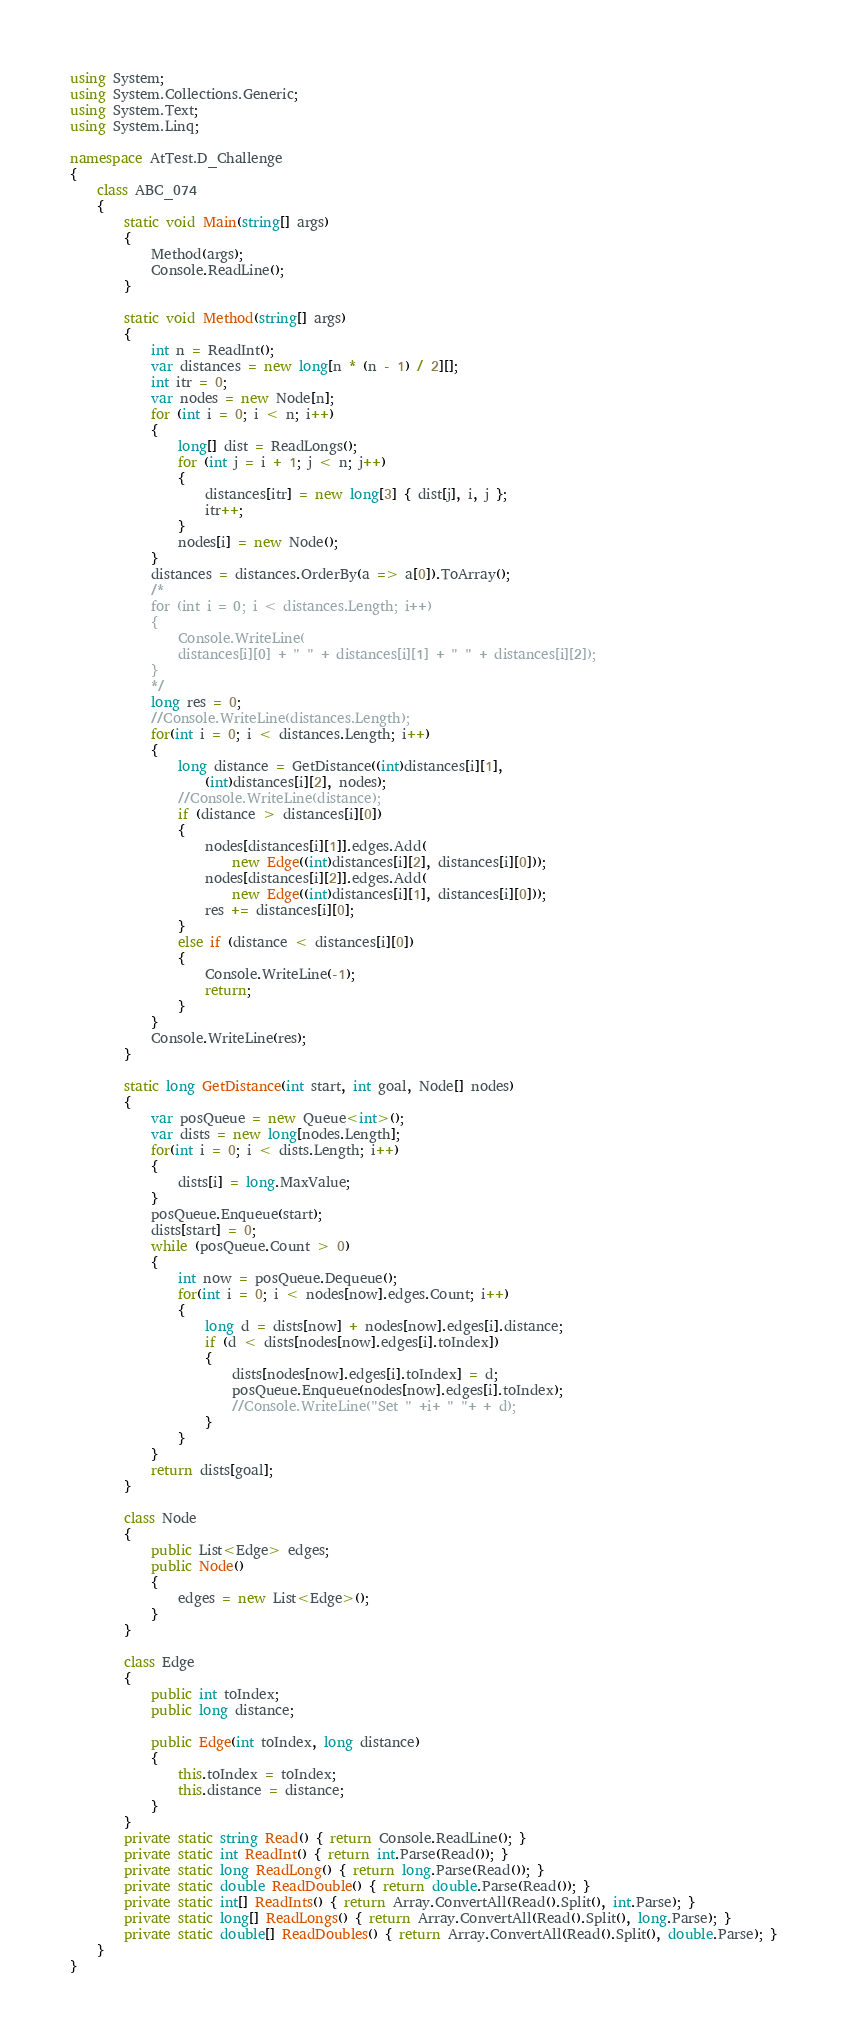Convert code to text. <code><loc_0><loc_0><loc_500><loc_500><_C#_>using System;
using System.Collections.Generic;
using System.Text;
using System.Linq;

namespace AtTest.D_Challenge
{
    class ABC_074
    {
        static void Main(string[] args)
        {
            Method(args);
            Console.ReadLine();
        }

        static void Method(string[] args)
        {
            int n = ReadInt();
            var distances = new long[n * (n - 1) / 2][];
            int itr = 0;
            var nodes = new Node[n];
            for (int i = 0; i < n; i++)
            {
                long[] dist = ReadLongs();
                for (int j = i + 1; j < n; j++)
                {
                    distances[itr] = new long[3] { dist[j], i, j };
                    itr++;
                }
                nodes[i] = new Node();
            }
            distances = distances.OrderBy(a => a[0]).ToArray();
            /*
            for (int i = 0; i < distances.Length; i++)
            {
                Console.WriteLine(
                distances[i][0] + " " + distances[i][1] + " " + distances[i][2]);
            }
            */
            long res = 0;
            //Console.WriteLine(distances.Length);
            for(int i = 0; i < distances.Length; i++)
            {
                long distance = GetDistance((int)distances[i][1],
                    (int)distances[i][2], nodes);
                //Console.WriteLine(distance);
                if (distance > distances[i][0])
                {
                    nodes[distances[i][1]].edges.Add(
                        new Edge((int)distances[i][2], distances[i][0]));
                    nodes[distances[i][2]].edges.Add(
                        new Edge((int)distances[i][1], distances[i][0]));
                    res += distances[i][0];
                }
                else if (distance < distances[i][0])
                {
                    Console.WriteLine(-1);
                    return;
                }
            }
            Console.WriteLine(res);
        }

        static long GetDistance(int start, int goal, Node[] nodes)
        {
            var posQueue = new Queue<int>();
            var dists = new long[nodes.Length];
            for(int i = 0; i < dists.Length; i++)
            {
                dists[i] = long.MaxValue;
            }
            posQueue.Enqueue(start);
            dists[start] = 0;
            while (posQueue.Count > 0)
            {
                int now = posQueue.Dequeue();
                for(int i = 0; i < nodes[now].edges.Count; i++)
                {
                    long d = dists[now] + nodes[now].edges[i].distance;
                    if (d < dists[nodes[now].edges[i].toIndex])
                    {
                        dists[nodes[now].edges[i].toIndex] = d;
                        posQueue.Enqueue(nodes[now].edges[i].toIndex);
                        //Console.WriteLine("Set " +i+ " "+ + d);
                    }
                }
            }
            return dists[goal];
        }

        class Node
        {
            public List<Edge> edges;
            public Node()
            {
                edges = new List<Edge>();
            }
        }

        class Edge
        {
            public int toIndex;
            public long distance;

            public Edge(int toIndex, long distance)
            {
                this.toIndex = toIndex;
                this.distance = distance;
            }
        }
        private static string Read() { return Console.ReadLine(); }
        private static int ReadInt() { return int.Parse(Read()); }
        private static long ReadLong() { return long.Parse(Read()); }
        private static double ReadDouble() { return double.Parse(Read()); }
        private static int[] ReadInts() { return Array.ConvertAll(Read().Split(), int.Parse); }
        private static long[] ReadLongs() { return Array.ConvertAll(Read().Split(), long.Parse); }
        private static double[] ReadDoubles() { return Array.ConvertAll(Read().Split(), double.Parse); }
    }
}
</code> 